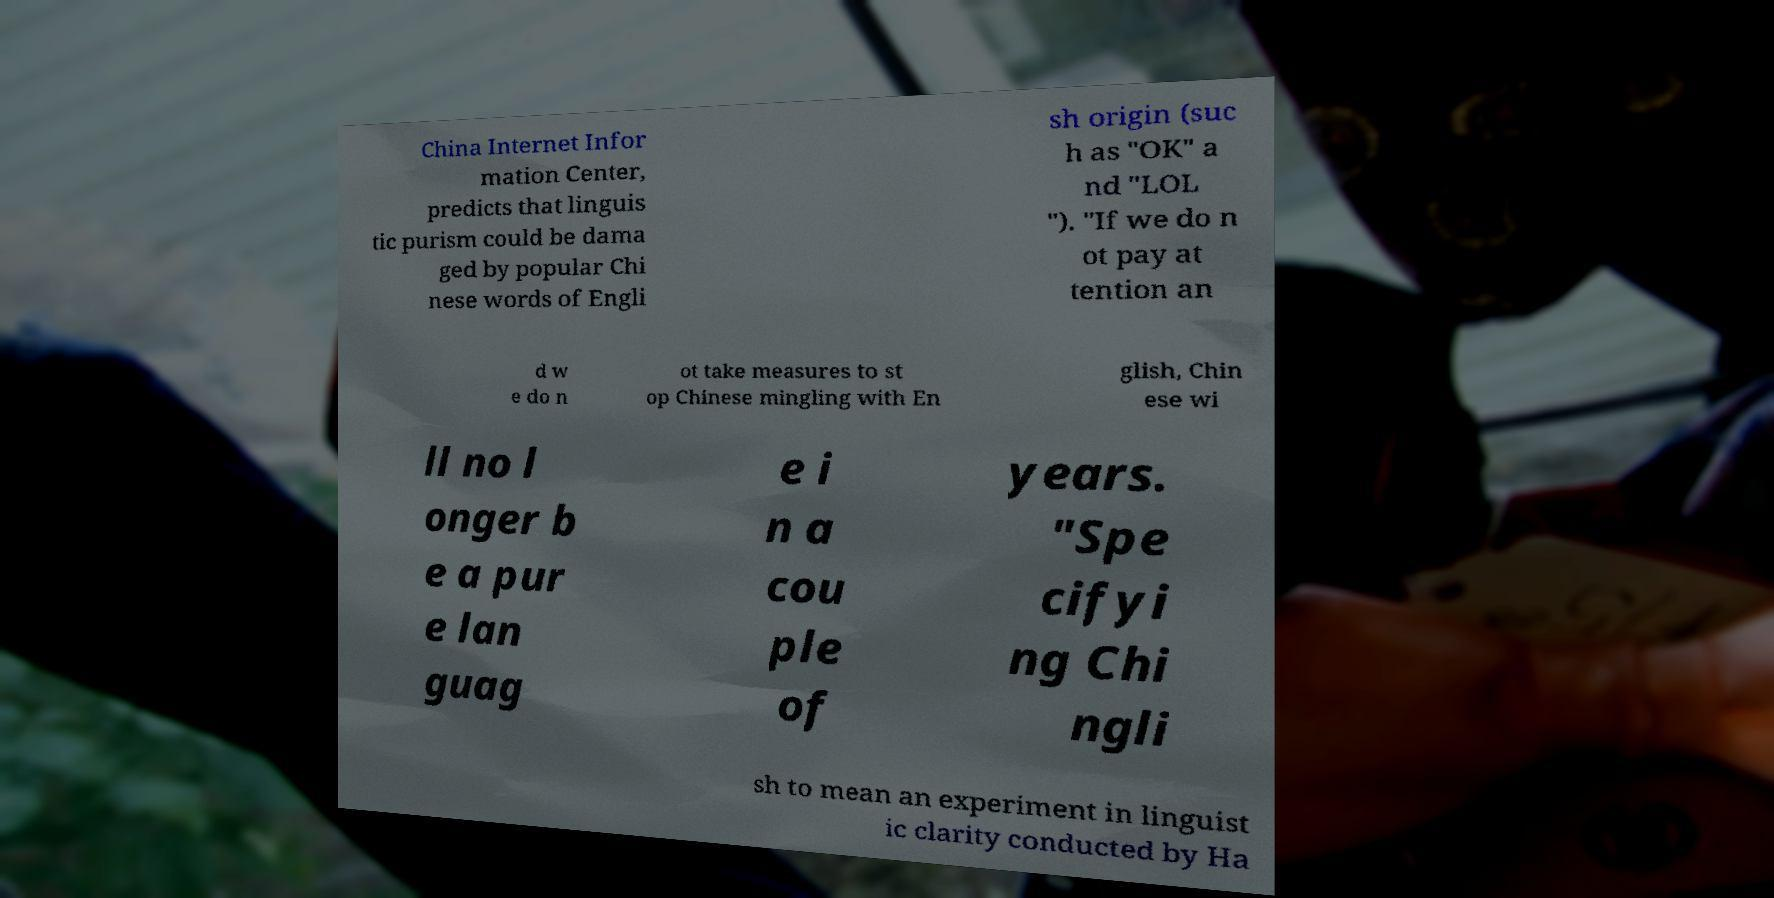I need the written content from this picture converted into text. Can you do that? China Internet Infor mation Center, predicts that linguis tic purism could be dama ged by popular Chi nese words of Engli sh origin (suc h as "OK" a nd "LOL "). "If we do n ot pay at tention an d w e do n ot take measures to st op Chinese mingling with En glish, Chin ese wi ll no l onger b e a pur e lan guag e i n a cou ple of years. "Spe cifyi ng Chi ngli sh to mean an experiment in linguist ic clarity conducted by Ha 